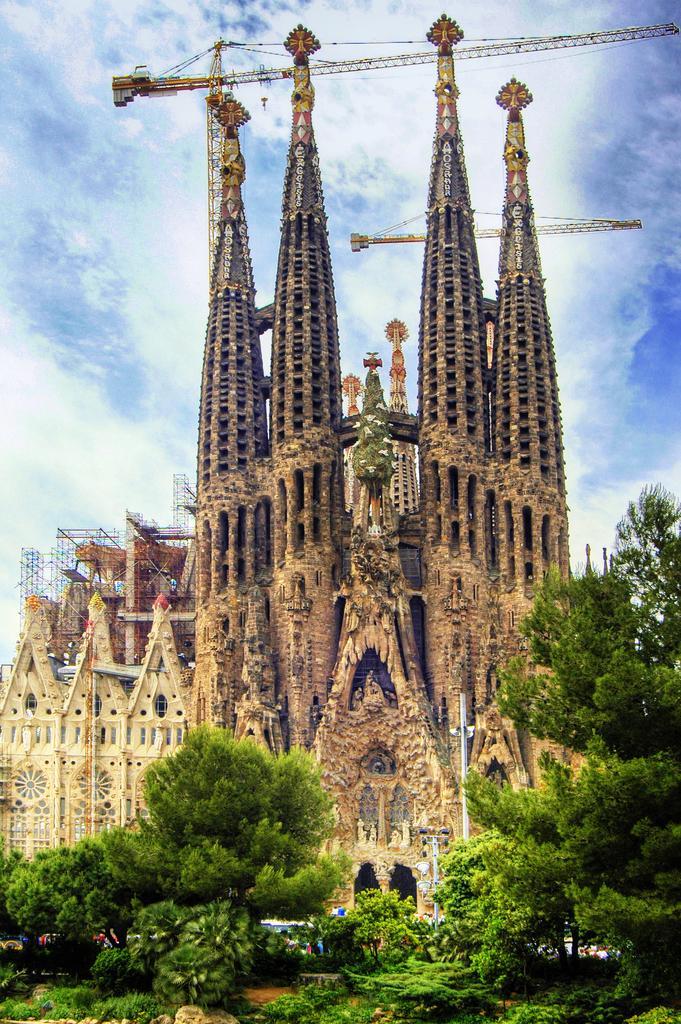Describe this image in one or two sentences. In this picture, we can see a few buildings, cranes, poles, ground with plants, trees, and the sky with clouds. 